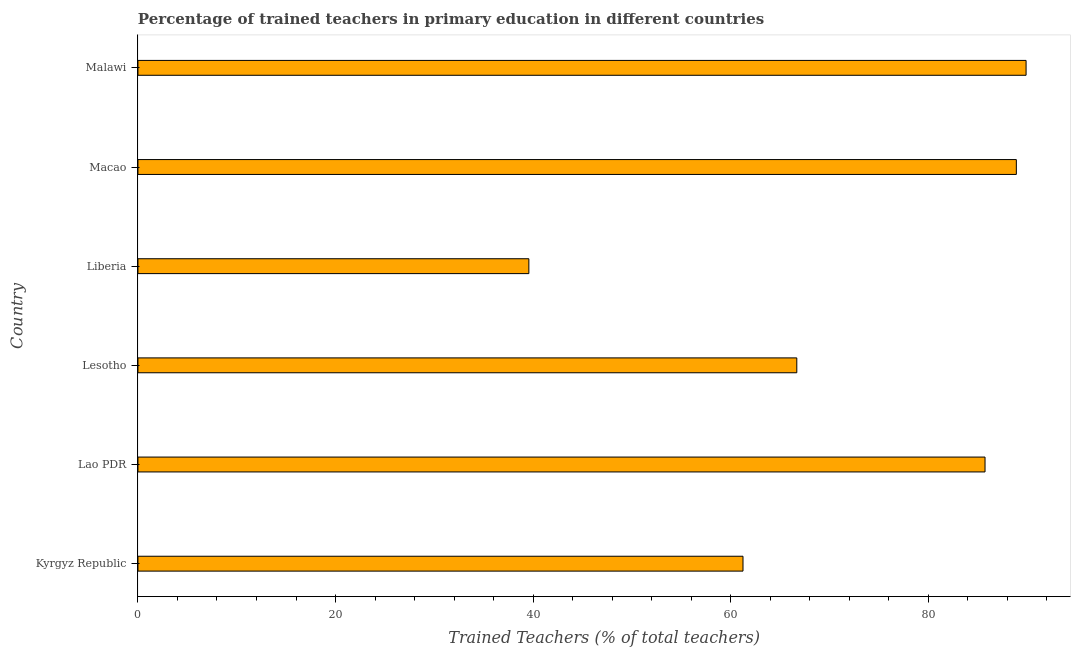Does the graph contain any zero values?
Offer a very short reply. No. Does the graph contain grids?
Ensure brevity in your answer.  No. What is the title of the graph?
Your answer should be very brief. Percentage of trained teachers in primary education in different countries. What is the label or title of the X-axis?
Ensure brevity in your answer.  Trained Teachers (% of total teachers). What is the label or title of the Y-axis?
Ensure brevity in your answer.  Country. What is the percentage of trained teachers in Liberia?
Your answer should be very brief. 39.58. Across all countries, what is the maximum percentage of trained teachers?
Ensure brevity in your answer.  89.92. Across all countries, what is the minimum percentage of trained teachers?
Your answer should be very brief. 39.58. In which country was the percentage of trained teachers maximum?
Provide a short and direct response. Malawi. In which country was the percentage of trained teachers minimum?
Your response must be concise. Liberia. What is the sum of the percentage of trained teachers?
Offer a very short reply. 432.14. What is the difference between the percentage of trained teachers in Lesotho and Malawi?
Provide a succinct answer. -23.21. What is the average percentage of trained teachers per country?
Your answer should be compact. 72.02. What is the median percentage of trained teachers?
Offer a very short reply. 76.23. In how many countries, is the percentage of trained teachers greater than 72 %?
Provide a succinct answer. 3. What is the ratio of the percentage of trained teachers in Kyrgyz Republic to that in Malawi?
Ensure brevity in your answer.  0.68. Is the percentage of trained teachers in Lao PDR less than that in Liberia?
Your response must be concise. No. Is the difference between the percentage of trained teachers in Liberia and Macao greater than the difference between any two countries?
Provide a short and direct response. No. What is the difference between the highest and the second highest percentage of trained teachers?
Give a very brief answer. 0.99. Is the sum of the percentage of trained teachers in Liberia and Malawi greater than the maximum percentage of trained teachers across all countries?
Provide a succinct answer. Yes. What is the difference between the highest and the lowest percentage of trained teachers?
Offer a terse response. 50.34. In how many countries, is the percentage of trained teachers greater than the average percentage of trained teachers taken over all countries?
Ensure brevity in your answer.  3. How many bars are there?
Provide a succinct answer. 6. Are all the bars in the graph horizontal?
Offer a terse response. Yes. What is the Trained Teachers (% of total teachers) of Kyrgyz Republic?
Ensure brevity in your answer.  61.26. What is the Trained Teachers (% of total teachers) in Lao PDR?
Offer a very short reply. 85.76. What is the Trained Teachers (% of total teachers) in Lesotho?
Your response must be concise. 66.7. What is the Trained Teachers (% of total teachers) in Liberia?
Make the answer very short. 39.58. What is the Trained Teachers (% of total teachers) in Macao?
Keep it short and to the point. 88.93. What is the Trained Teachers (% of total teachers) of Malawi?
Your answer should be compact. 89.92. What is the difference between the Trained Teachers (% of total teachers) in Kyrgyz Republic and Lao PDR?
Provide a short and direct response. -24.5. What is the difference between the Trained Teachers (% of total teachers) in Kyrgyz Republic and Lesotho?
Keep it short and to the point. -5.45. What is the difference between the Trained Teachers (% of total teachers) in Kyrgyz Republic and Liberia?
Give a very brief answer. 21.68. What is the difference between the Trained Teachers (% of total teachers) in Kyrgyz Republic and Macao?
Keep it short and to the point. -27.67. What is the difference between the Trained Teachers (% of total teachers) in Kyrgyz Republic and Malawi?
Offer a very short reply. -28.66. What is the difference between the Trained Teachers (% of total teachers) in Lao PDR and Lesotho?
Keep it short and to the point. 19.06. What is the difference between the Trained Teachers (% of total teachers) in Lao PDR and Liberia?
Your answer should be very brief. 46.18. What is the difference between the Trained Teachers (% of total teachers) in Lao PDR and Macao?
Your answer should be compact. -3.17. What is the difference between the Trained Teachers (% of total teachers) in Lao PDR and Malawi?
Your answer should be very brief. -4.16. What is the difference between the Trained Teachers (% of total teachers) in Lesotho and Liberia?
Your answer should be very brief. 27.13. What is the difference between the Trained Teachers (% of total teachers) in Lesotho and Macao?
Your response must be concise. -22.23. What is the difference between the Trained Teachers (% of total teachers) in Lesotho and Malawi?
Ensure brevity in your answer.  -23.21. What is the difference between the Trained Teachers (% of total teachers) in Liberia and Macao?
Make the answer very short. -49.35. What is the difference between the Trained Teachers (% of total teachers) in Liberia and Malawi?
Make the answer very short. -50.34. What is the difference between the Trained Teachers (% of total teachers) in Macao and Malawi?
Provide a succinct answer. -0.99. What is the ratio of the Trained Teachers (% of total teachers) in Kyrgyz Republic to that in Lao PDR?
Provide a short and direct response. 0.71. What is the ratio of the Trained Teachers (% of total teachers) in Kyrgyz Republic to that in Lesotho?
Offer a very short reply. 0.92. What is the ratio of the Trained Teachers (% of total teachers) in Kyrgyz Republic to that in Liberia?
Keep it short and to the point. 1.55. What is the ratio of the Trained Teachers (% of total teachers) in Kyrgyz Republic to that in Macao?
Provide a succinct answer. 0.69. What is the ratio of the Trained Teachers (% of total teachers) in Kyrgyz Republic to that in Malawi?
Ensure brevity in your answer.  0.68. What is the ratio of the Trained Teachers (% of total teachers) in Lao PDR to that in Lesotho?
Your answer should be compact. 1.29. What is the ratio of the Trained Teachers (% of total teachers) in Lao PDR to that in Liberia?
Give a very brief answer. 2.17. What is the ratio of the Trained Teachers (% of total teachers) in Lao PDR to that in Macao?
Keep it short and to the point. 0.96. What is the ratio of the Trained Teachers (% of total teachers) in Lao PDR to that in Malawi?
Offer a terse response. 0.95. What is the ratio of the Trained Teachers (% of total teachers) in Lesotho to that in Liberia?
Your answer should be compact. 1.69. What is the ratio of the Trained Teachers (% of total teachers) in Lesotho to that in Malawi?
Provide a short and direct response. 0.74. What is the ratio of the Trained Teachers (% of total teachers) in Liberia to that in Macao?
Offer a terse response. 0.45. What is the ratio of the Trained Teachers (% of total teachers) in Liberia to that in Malawi?
Ensure brevity in your answer.  0.44. 